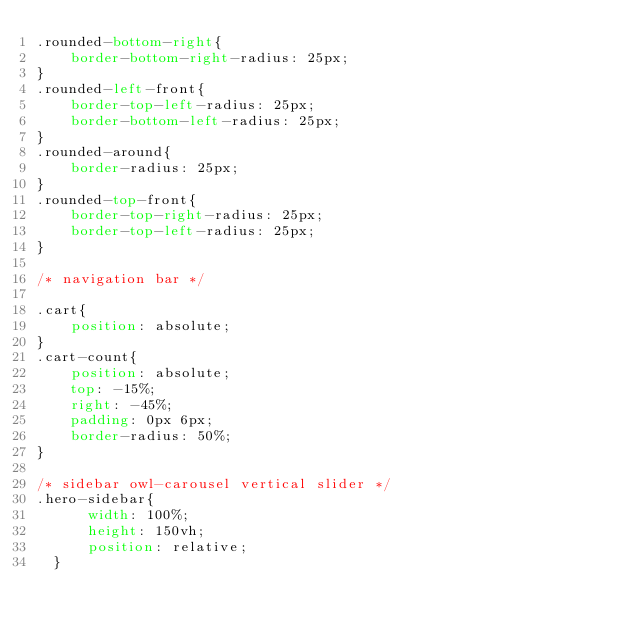Convert code to text. <code><loc_0><loc_0><loc_500><loc_500><_CSS_>.rounded-bottom-right{
    border-bottom-right-radius: 25px;
}
.rounded-left-front{
    border-top-left-radius: 25px;
    border-bottom-left-radius: 25px;
}
.rounded-around{
    border-radius: 25px;
}
.rounded-top-front{
    border-top-right-radius: 25px;
    border-top-left-radius: 25px;
}

/* navigation bar */

.cart{
    position: absolute;
}
.cart-count{
    position: absolute;
    top: -15%;
    right: -45%;
    padding: 0px 6px;
    border-radius: 50%;
}

/* sidebar owl-carousel vertical slider */
.hero-sidebar{
      width: 100%;
      height: 150vh;
      position: relative;
  }</code> 